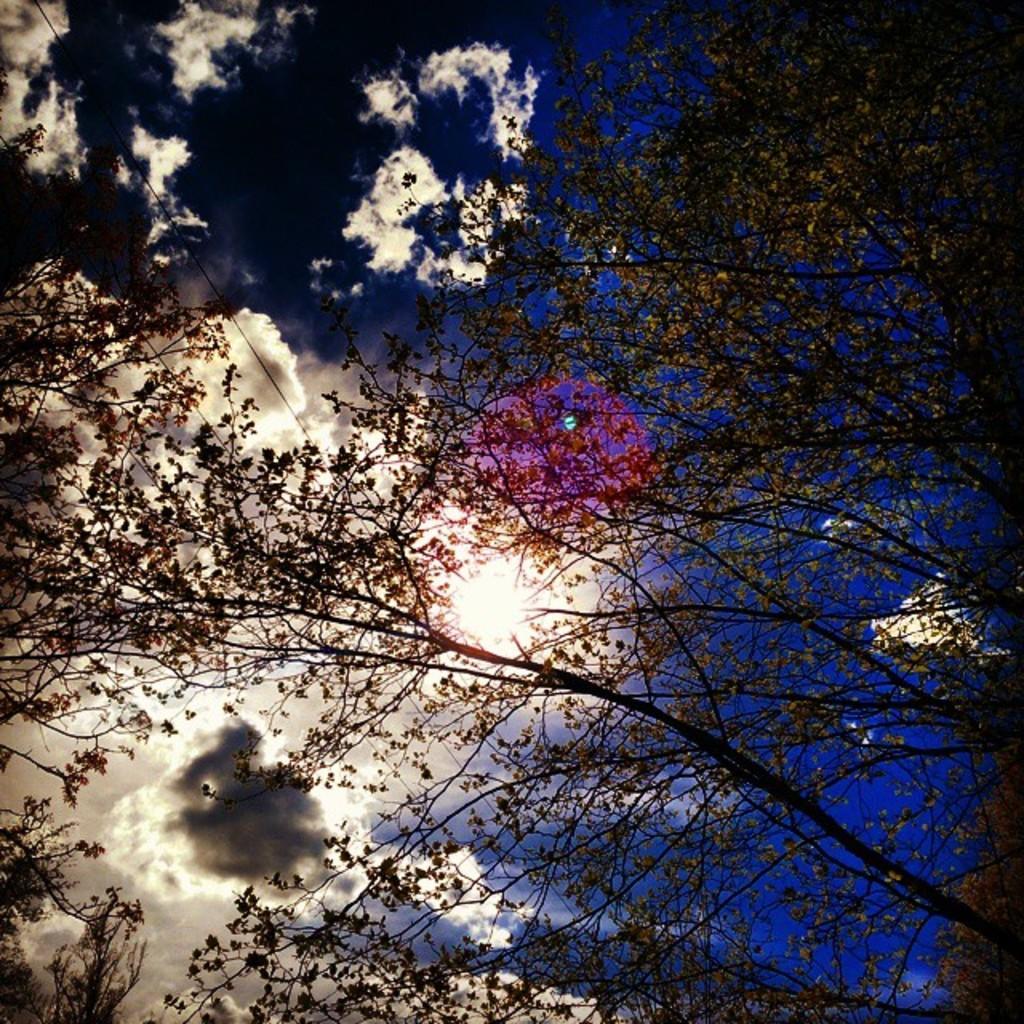Could you give a brief overview of what you see in this image? In this image, there are a few trees. We can also see the sky with clouds. 